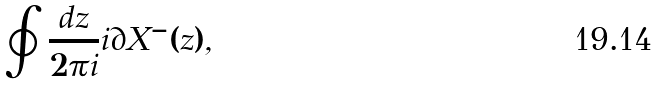<formula> <loc_0><loc_0><loc_500><loc_500>\oint \frac { d z } { 2 \pi i } i \partial X ^ { - } ( z ) ,</formula> 